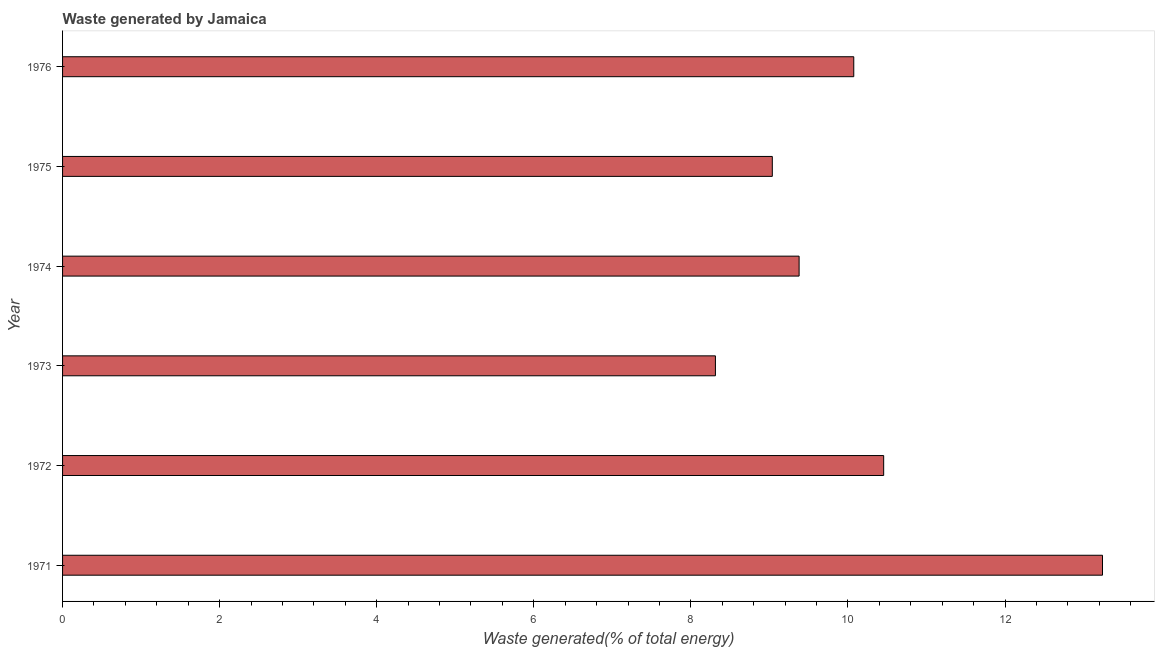Does the graph contain grids?
Keep it short and to the point. No. What is the title of the graph?
Give a very brief answer. Waste generated by Jamaica. What is the label or title of the X-axis?
Your answer should be very brief. Waste generated(% of total energy). What is the label or title of the Y-axis?
Make the answer very short. Year. What is the amount of waste generated in 1972?
Provide a succinct answer. 10.45. Across all years, what is the maximum amount of waste generated?
Your response must be concise. 13.24. Across all years, what is the minimum amount of waste generated?
Your answer should be compact. 8.31. What is the sum of the amount of waste generated?
Offer a very short reply. 60.49. What is the difference between the amount of waste generated in 1971 and 1976?
Offer a very short reply. 3.17. What is the average amount of waste generated per year?
Offer a very short reply. 10.08. What is the median amount of waste generated?
Provide a succinct answer. 9.73. In how many years, is the amount of waste generated greater than 12.8 %?
Provide a succinct answer. 1. What is the ratio of the amount of waste generated in 1971 to that in 1973?
Make the answer very short. 1.59. Is the difference between the amount of waste generated in 1971 and 1974 greater than the difference between any two years?
Provide a succinct answer. No. What is the difference between the highest and the second highest amount of waste generated?
Give a very brief answer. 2.79. Is the sum of the amount of waste generated in 1972 and 1976 greater than the maximum amount of waste generated across all years?
Ensure brevity in your answer.  Yes. What is the difference between the highest and the lowest amount of waste generated?
Provide a short and direct response. 4.93. How many bars are there?
Your answer should be very brief. 6. Are all the bars in the graph horizontal?
Keep it short and to the point. Yes. What is the difference between two consecutive major ticks on the X-axis?
Keep it short and to the point. 2. Are the values on the major ticks of X-axis written in scientific E-notation?
Provide a succinct answer. No. What is the Waste generated(% of total energy) of 1971?
Offer a very short reply. 13.24. What is the Waste generated(% of total energy) of 1972?
Provide a short and direct response. 10.45. What is the Waste generated(% of total energy) in 1973?
Keep it short and to the point. 8.31. What is the Waste generated(% of total energy) in 1974?
Offer a terse response. 9.38. What is the Waste generated(% of total energy) in 1975?
Offer a very short reply. 9.04. What is the Waste generated(% of total energy) of 1976?
Provide a short and direct response. 10.07. What is the difference between the Waste generated(% of total energy) in 1971 and 1972?
Ensure brevity in your answer.  2.79. What is the difference between the Waste generated(% of total energy) in 1971 and 1973?
Make the answer very short. 4.93. What is the difference between the Waste generated(% of total energy) in 1971 and 1974?
Provide a succinct answer. 3.86. What is the difference between the Waste generated(% of total energy) in 1971 and 1975?
Keep it short and to the point. 4.2. What is the difference between the Waste generated(% of total energy) in 1971 and 1976?
Offer a very short reply. 3.17. What is the difference between the Waste generated(% of total energy) in 1972 and 1973?
Your answer should be very brief. 2.14. What is the difference between the Waste generated(% of total energy) in 1972 and 1974?
Make the answer very short. 1.08. What is the difference between the Waste generated(% of total energy) in 1972 and 1975?
Your answer should be compact. 1.42. What is the difference between the Waste generated(% of total energy) in 1972 and 1976?
Your answer should be compact. 0.38. What is the difference between the Waste generated(% of total energy) in 1973 and 1974?
Keep it short and to the point. -1.07. What is the difference between the Waste generated(% of total energy) in 1973 and 1975?
Offer a terse response. -0.72. What is the difference between the Waste generated(% of total energy) in 1973 and 1976?
Your response must be concise. -1.76. What is the difference between the Waste generated(% of total energy) in 1974 and 1975?
Keep it short and to the point. 0.34. What is the difference between the Waste generated(% of total energy) in 1974 and 1976?
Offer a very short reply. -0.7. What is the difference between the Waste generated(% of total energy) in 1975 and 1976?
Ensure brevity in your answer.  -1.04. What is the ratio of the Waste generated(% of total energy) in 1971 to that in 1972?
Offer a very short reply. 1.27. What is the ratio of the Waste generated(% of total energy) in 1971 to that in 1973?
Provide a short and direct response. 1.59. What is the ratio of the Waste generated(% of total energy) in 1971 to that in 1974?
Provide a short and direct response. 1.41. What is the ratio of the Waste generated(% of total energy) in 1971 to that in 1975?
Your response must be concise. 1.47. What is the ratio of the Waste generated(% of total energy) in 1971 to that in 1976?
Provide a short and direct response. 1.31. What is the ratio of the Waste generated(% of total energy) in 1972 to that in 1973?
Give a very brief answer. 1.26. What is the ratio of the Waste generated(% of total energy) in 1972 to that in 1974?
Provide a succinct answer. 1.11. What is the ratio of the Waste generated(% of total energy) in 1972 to that in 1975?
Offer a terse response. 1.16. What is the ratio of the Waste generated(% of total energy) in 1972 to that in 1976?
Ensure brevity in your answer.  1.04. What is the ratio of the Waste generated(% of total energy) in 1973 to that in 1974?
Your answer should be very brief. 0.89. What is the ratio of the Waste generated(% of total energy) in 1973 to that in 1975?
Provide a short and direct response. 0.92. What is the ratio of the Waste generated(% of total energy) in 1973 to that in 1976?
Offer a very short reply. 0.82. What is the ratio of the Waste generated(% of total energy) in 1974 to that in 1975?
Ensure brevity in your answer.  1.04. What is the ratio of the Waste generated(% of total energy) in 1974 to that in 1976?
Offer a very short reply. 0.93. What is the ratio of the Waste generated(% of total energy) in 1975 to that in 1976?
Ensure brevity in your answer.  0.9. 